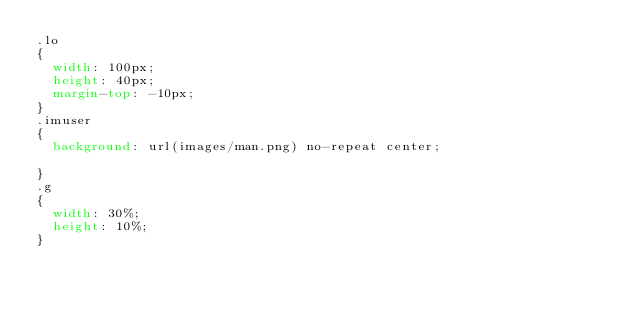<code> <loc_0><loc_0><loc_500><loc_500><_CSS_>.lo
{
	width: 100px; 
	height: 40px; 
	margin-top: -10px;
}
.imuser
{
	background: url(images/man.png) no-repeat center;

}
.g
{
	width: 30%; 
	height: 10%;
}</code> 